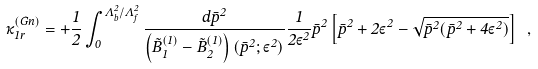<formula> <loc_0><loc_0><loc_500><loc_500>\kappa _ { 1 r } ^ { ( G n ) } = + \frac { 1 } { 2 } \int _ { 0 } ^ { { \Lambda } _ { b } ^ { 2 } / { \Lambda } _ { f } ^ { 2 } } \frac { d { \bar { p } } ^ { 2 } } { \left ( { \tilde { B } } _ { 1 } ^ { ( 1 ) } - { \tilde { B } } _ { 2 } ^ { ( 1 ) } \right ) \left ( { \bar { p } } ^ { 2 } ; { \varepsilon } ^ { 2 } \right ) } \frac { 1 } { 2 { \varepsilon } ^ { 2 } } { \bar { p } } ^ { 2 } \left [ { \bar { p } } ^ { 2 } + 2 { \varepsilon } ^ { 2 } - \sqrt { { \bar { p } } ^ { 2 } ( { \bar { p } } ^ { 2 } + 4 { \varepsilon } ^ { 2 } ) } \right ] \ ,</formula> 